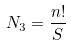Convert formula to latex. <formula><loc_0><loc_0><loc_500><loc_500>N _ { 3 } = \frac { n ! } { S }</formula> 